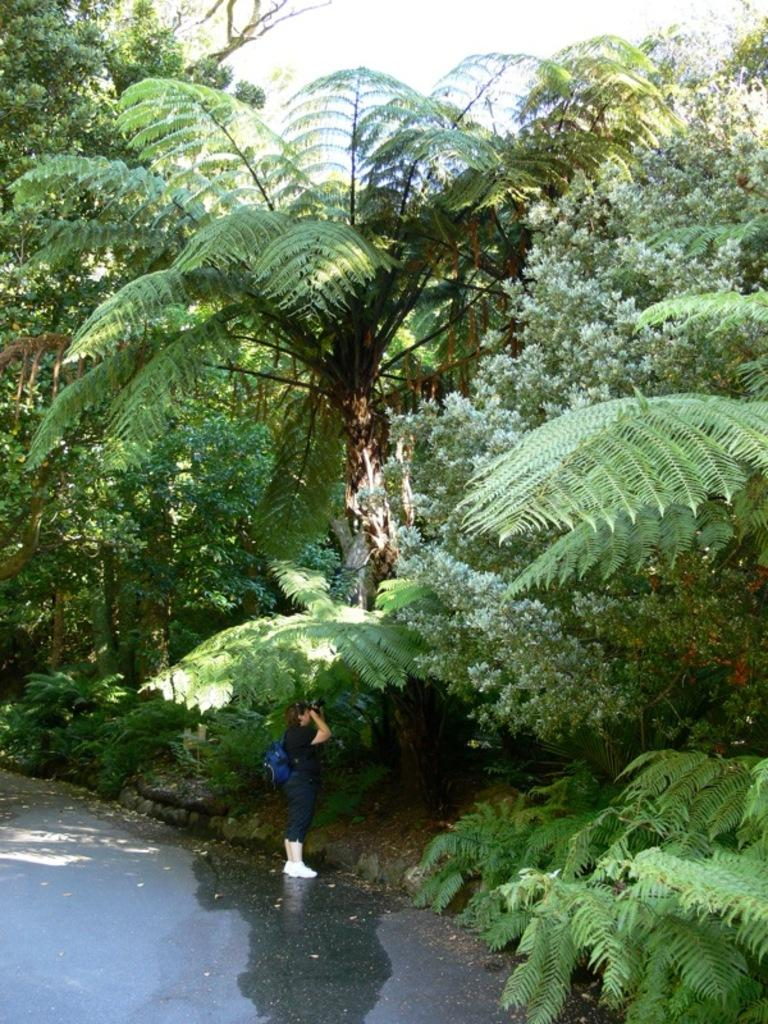What is the main subject of the image? There is a person standing in the center of the image. What is the person wearing? The person is wearing a bag. What can be seen in the background of the image? There are trees in the background of the image. What is at the bottom of the image? There is a walkway at the bottom of the image. What type of ray can be seen swimming near the person in the image? There is no ray present in the image; it features a person standing in the center of the image. Is there an umbrella being used by the person in the image? There is no umbrella visible in the image. 